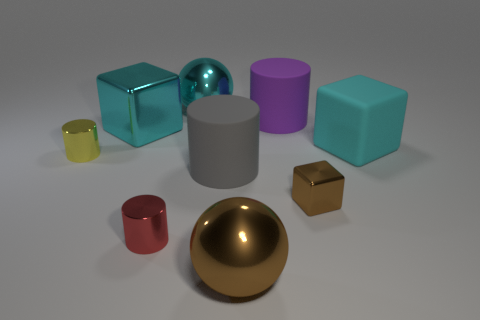There is a large object that is the same color as the tiny metal block; what shape is it?
Your answer should be very brief. Sphere. What number of red metallic blocks have the same size as the cyan rubber cube?
Provide a succinct answer. 0. There is a big cylinder to the left of the purple matte object; are there any cyan metal spheres in front of it?
Your answer should be very brief. No. How many objects are gray cylinders or brown metallic objects?
Your response must be concise. 3. There is a large thing that is on the left side of the cylinder that is in front of the large matte thing that is in front of the small yellow metal cylinder; what is its color?
Keep it short and to the point. Cyan. Is there any other thing that has the same color as the small metallic cube?
Offer a terse response. Yes. Is the yellow shiny cylinder the same size as the matte cube?
Offer a very short reply. No. How many objects are either brown things that are in front of the tiny brown block or brown spheres to the right of the cyan sphere?
Your response must be concise. 1. What is the material of the tiny yellow cylinder that is in front of the matte cylinder that is on the right side of the gray matte cylinder?
Keep it short and to the point. Metal. How many other things are made of the same material as the big purple thing?
Offer a very short reply. 2. 